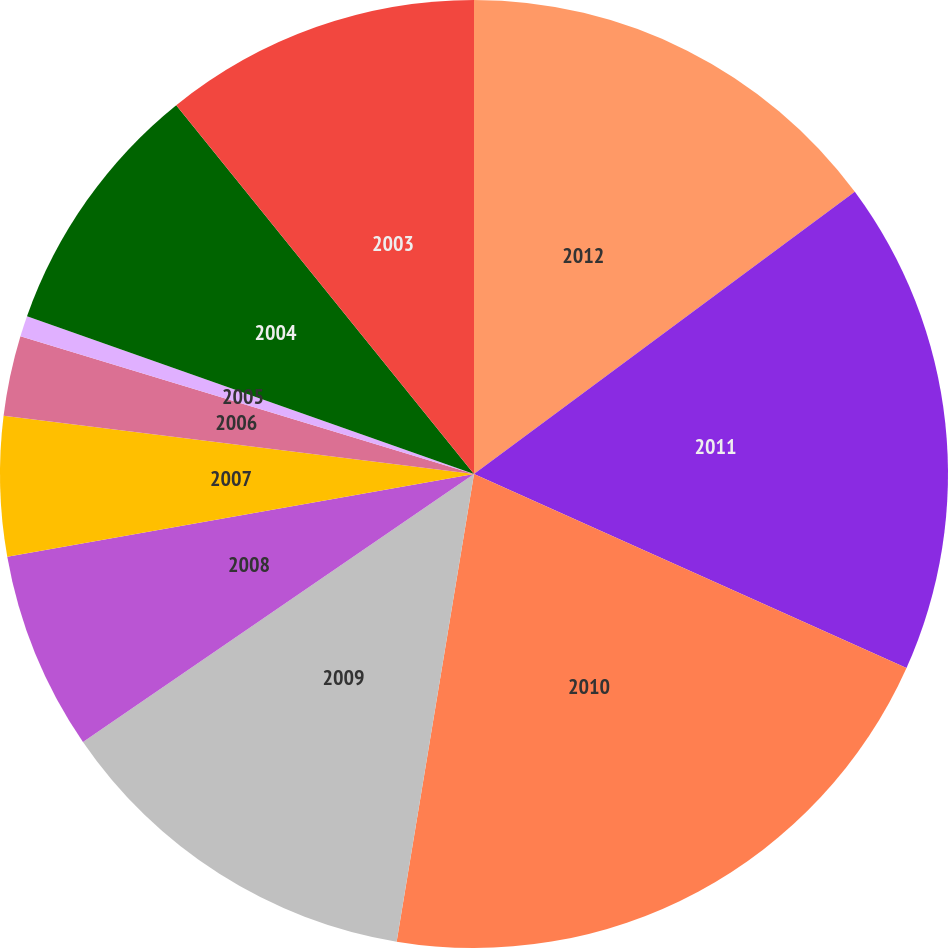Convert chart to OTSL. <chart><loc_0><loc_0><loc_500><loc_500><pie_chart><fcel>2012<fcel>2011<fcel>2010<fcel>2009<fcel>2008<fcel>2007<fcel>2006<fcel>2005<fcel>2004<fcel>2003<nl><fcel>14.85%<fcel>16.86%<fcel>20.9%<fcel>12.83%<fcel>6.77%<fcel>4.75%<fcel>2.73%<fcel>0.71%<fcel>8.79%<fcel>10.81%<nl></chart> 